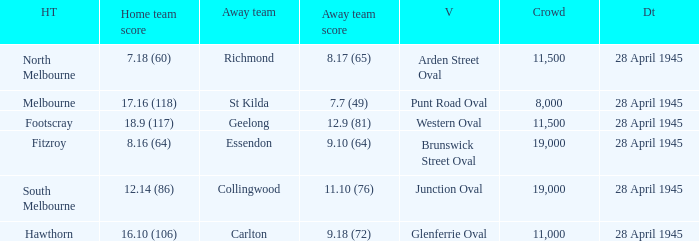What away team played at western oval? Geelong. 